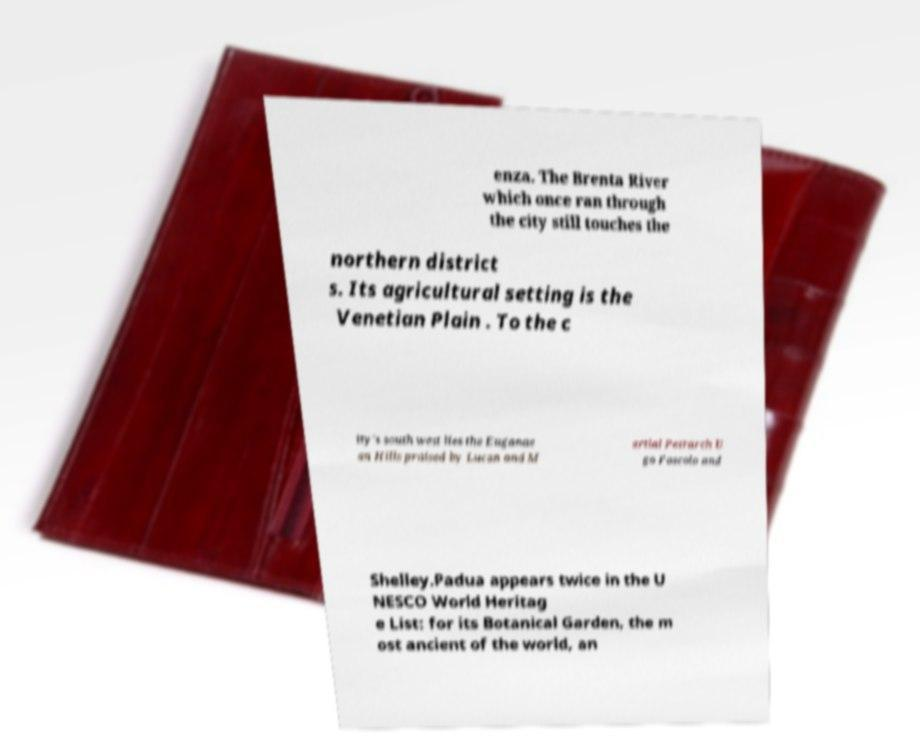Could you extract and type out the text from this image? enza. The Brenta River which once ran through the city still touches the northern district s. Its agricultural setting is the Venetian Plain . To the c ity's south west lies the Euganae an Hills praised by Lucan and M artial Petrarch U go Foscolo and Shelley.Padua appears twice in the U NESCO World Heritag e List: for its Botanical Garden, the m ost ancient of the world, an 